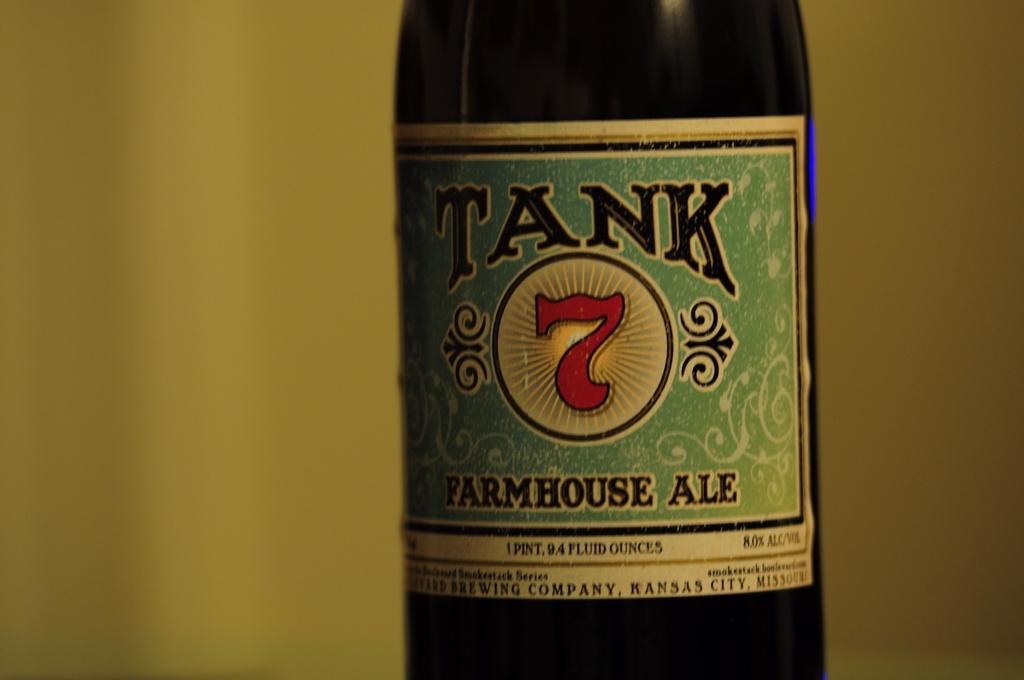How would you summarize this image in a sentence or two? This is a picture of a bottle on which some text is written. 